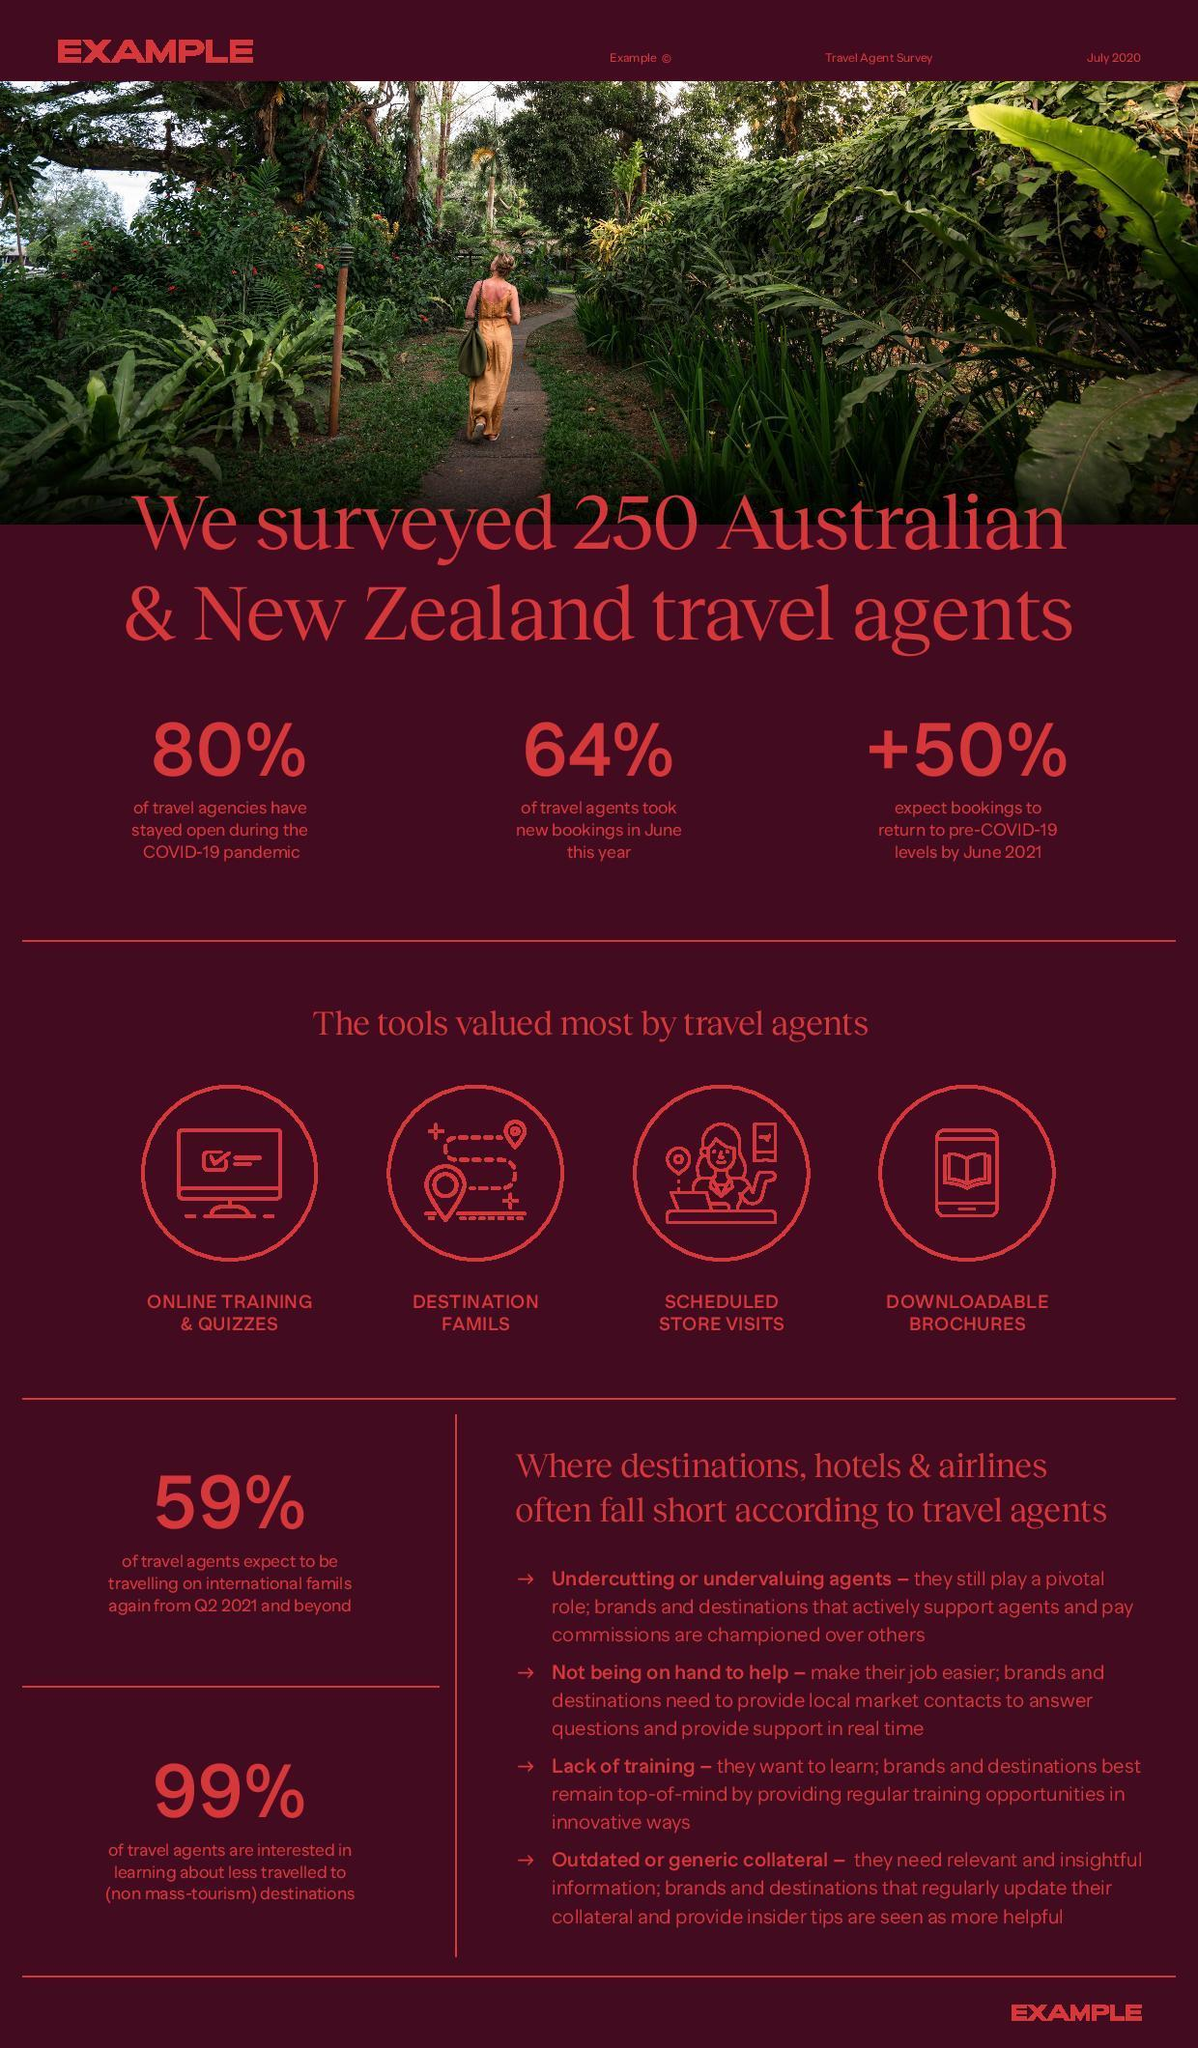What is the percent increase expected in the bookings to return to pre-COVID-19 levels by June 2021 according to the survey?
Answer the question with a short phrase. 50% What percent of Australian & New Zealand travel agents took new bookings in June this year according to the survey? 64% What percent of travel agencies in Australia & New Zealand didn't stay open during the COVID-19 pandemic according to the survey? 20% What percent of Australian & New Zealand travel agents are not interested in learning about less travelled to destinations as per the survey? 1% 